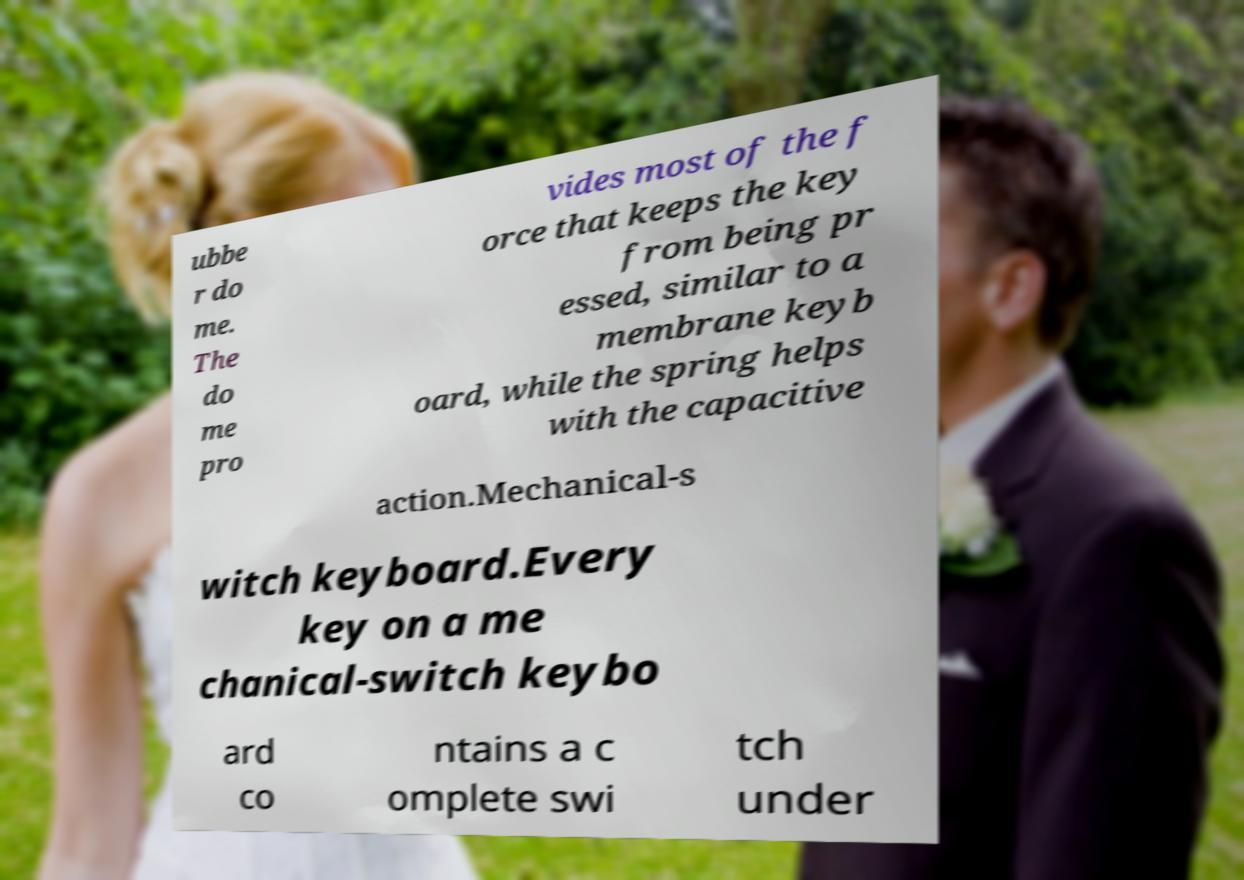Could you extract and type out the text from this image? ubbe r do me. The do me pro vides most of the f orce that keeps the key from being pr essed, similar to a membrane keyb oard, while the spring helps with the capacitive action.Mechanical-s witch keyboard.Every key on a me chanical-switch keybo ard co ntains a c omplete swi tch under 